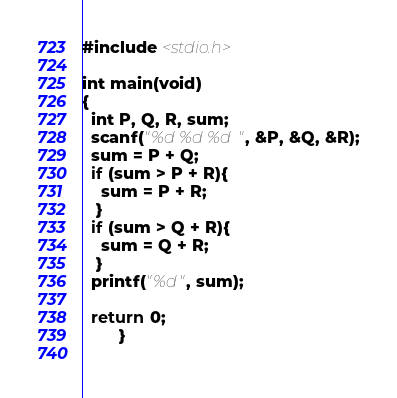<code> <loc_0><loc_0><loc_500><loc_500><_C_>#include <stdio.h>

int main(void)
{
  int P, Q, R, sum;
  scanf("%d %d %d", &P, &Q, &R);
  sum = P + Q;
  if (sum > P + R){
    sum = P + R;
   }
  if (sum > Q + R){
    sum = Q + R;
   }
  printf("%d", sum);
  
  return 0;
        }
  </code> 